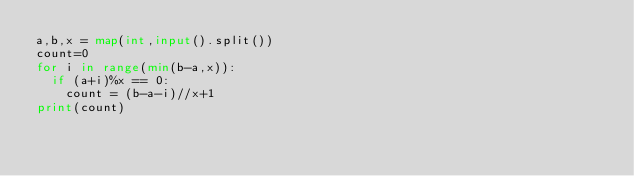<code> <loc_0><loc_0><loc_500><loc_500><_Python_>a,b,x = map(int,input().split())
count=0
for i in range(min(b-a,x)):
  if (a+i)%x == 0:
    count = (b-a-i)//x+1
print(count)</code> 